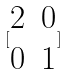Convert formula to latex. <formula><loc_0><loc_0><loc_500><loc_500>[ \begin{matrix} 2 & 0 \\ 0 & 1 \end{matrix} ]</formula> 